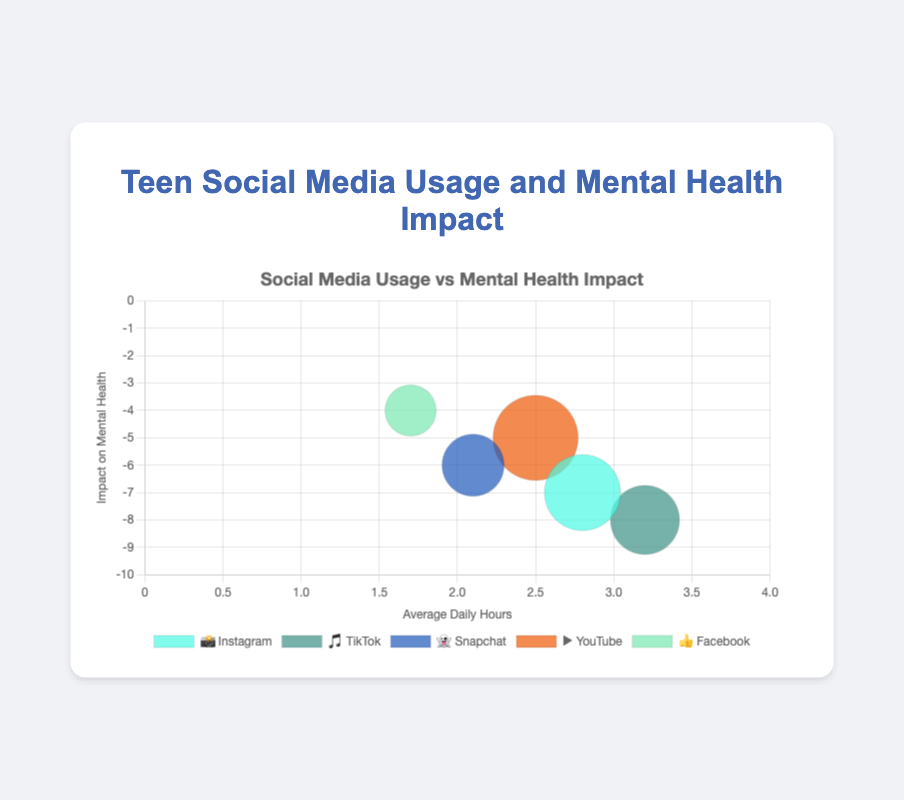Which social media platform has the highest usage percentage? The chart shows various social media platforms and their usage percentages. By looking at the bubble size (which represents the usage percentage), YouTube (▶️) has the largest bubble, indicating it has the highest usage percentage.
Answer: YouTube (▶️) What is the average daily hours spent on TikTok? The chart indicates each platform's average daily usage hours along the x-axis. The bubble labeled 🎵 represents TikTok, and it's positioned at 3.2 on the x-axis.
Answer: 3.2 hours Which platform has the least negative impact on mental health? The y-axis shows the impact on mental health, with values closer to zero being less negative. The bubble for Facebook (👍) is the highest on the y-axis, indicating it has the least negative impact.
Answer: Facebook (👍) How many social media platforms have a usage percentage greater than 60%? Bubbles with a radius indicating usage percentage greater than 60% include Instagram (📸), TikTok (🎵), Snapchat (👻), and YouTube (▶️). Count these bubbles to determine the total number.
Answer: 4 platforms Which platform is used the least by teenagers? The smallest bubble indicates the platform with the lowest usage percentage. The smallest bubble corresponds to Facebook (👍).
Answer: Facebook (👍) Which platform has the highest negative impact on mental health? The y-axis shows negative impacts, with the lower values indicating more negative impacts. The bubble for TikTok (🎵) is positioned lowest on the y-axis, meaning it has the highest negative impact.
Answer: TikTok (🎵) Which two platforms have the closest average daily hours? Look along the x-axis to find bubbles closest together. Instagram (📸) at 2.8 hours and YouTube (▶️) at 2.5 hours are the closest in average daily hours.
Answer: Instagram (📸) and YouTube (▶️) Which social media platforms have negative impacts greater than -6 on mental health? Find bubbles positioned lower than -6 on the y-axis. Instagram (📸) at -7 and TikTok (🎵) at -8 have impacts greater than -6.
Answer: Instagram (📸) and TikTok (🎵) If a teenager uses Instagram and Snapchat for the average daily hours, how much total time do they spend? Instagram average daily hours (2.8) + Snapchat average daily hours (2.1). Sum these values to get the total time.
Answer: 4.9 hours Which platform has a similar usage percentage to TikTok? Find bubbles similar in size to TikTok (🎵) based on the usage percentage. Snapchat (👻) has a usage percentage of 62%, close to TikTok's 69%.
Answer: Snapchat (👻) 